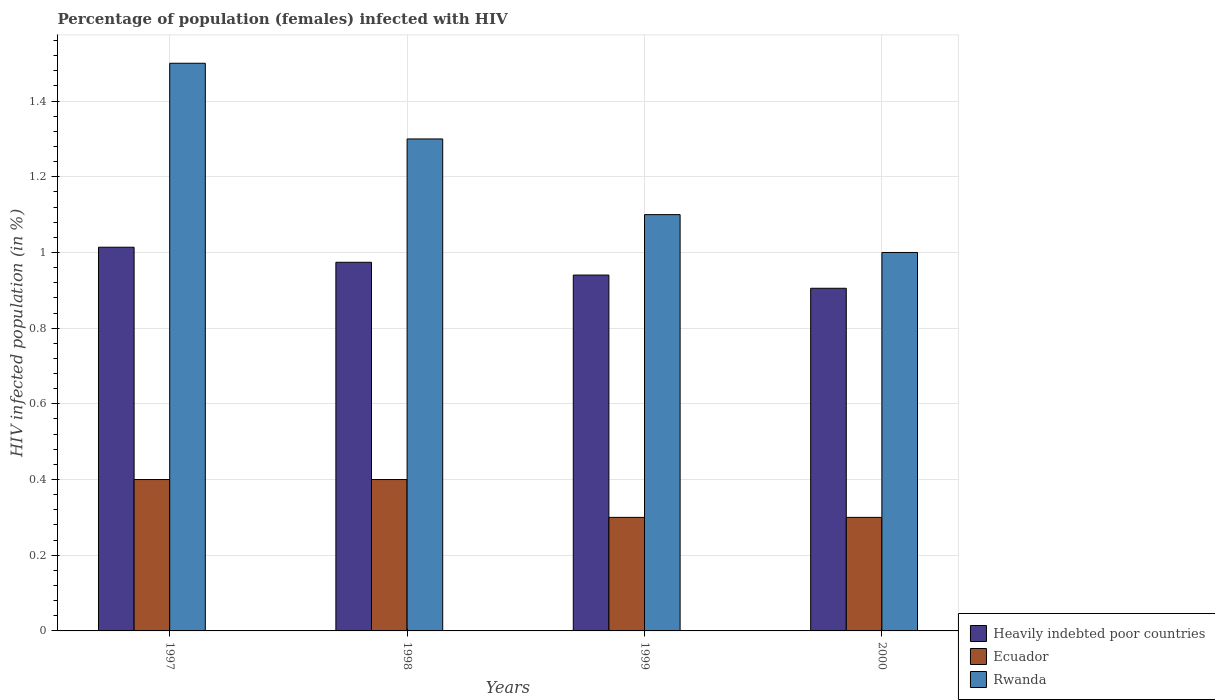How many different coloured bars are there?
Offer a very short reply. 3. How many groups of bars are there?
Offer a terse response. 4. Are the number of bars on each tick of the X-axis equal?
Provide a succinct answer. Yes. What is the label of the 4th group of bars from the left?
Provide a succinct answer. 2000. In how many cases, is the number of bars for a given year not equal to the number of legend labels?
Give a very brief answer. 0. Across all years, what is the maximum percentage of HIV infected female population in Heavily indebted poor countries?
Your answer should be compact. 1.01. In which year was the percentage of HIV infected female population in Heavily indebted poor countries maximum?
Ensure brevity in your answer.  1997. In which year was the percentage of HIV infected female population in Rwanda minimum?
Ensure brevity in your answer.  2000. What is the total percentage of HIV infected female population in Ecuador in the graph?
Provide a succinct answer. 1.4. What is the difference between the percentage of HIV infected female population in Ecuador in 1998 and that in 1999?
Offer a very short reply. 0.1. What is the average percentage of HIV infected female population in Rwanda per year?
Your answer should be very brief. 1.23. In the year 1997, what is the difference between the percentage of HIV infected female population in Heavily indebted poor countries and percentage of HIV infected female population in Rwanda?
Ensure brevity in your answer.  -0.49. What is the ratio of the percentage of HIV infected female population in Rwanda in 1998 to that in 2000?
Your answer should be compact. 1.3. Is the difference between the percentage of HIV infected female population in Heavily indebted poor countries in 1998 and 2000 greater than the difference between the percentage of HIV infected female population in Rwanda in 1998 and 2000?
Provide a succinct answer. No. What is the difference between the highest and the second highest percentage of HIV infected female population in Ecuador?
Offer a very short reply. 0. What does the 1st bar from the left in 2000 represents?
Your answer should be very brief. Heavily indebted poor countries. What does the 3rd bar from the right in 1998 represents?
Provide a short and direct response. Heavily indebted poor countries. How many bars are there?
Offer a terse response. 12. Are all the bars in the graph horizontal?
Your answer should be very brief. No. Does the graph contain grids?
Provide a succinct answer. Yes. Where does the legend appear in the graph?
Provide a succinct answer. Bottom right. How are the legend labels stacked?
Provide a succinct answer. Vertical. What is the title of the graph?
Offer a very short reply. Percentage of population (females) infected with HIV. Does "Croatia" appear as one of the legend labels in the graph?
Your response must be concise. No. What is the label or title of the Y-axis?
Give a very brief answer. HIV infected population (in %). What is the HIV infected population (in %) in Heavily indebted poor countries in 1997?
Offer a very short reply. 1.01. What is the HIV infected population (in %) of Ecuador in 1997?
Provide a short and direct response. 0.4. What is the HIV infected population (in %) of Rwanda in 1997?
Give a very brief answer. 1.5. What is the HIV infected population (in %) of Heavily indebted poor countries in 1998?
Make the answer very short. 0.97. What is the HIV infected population (in %) in Ecuador in 1998?
Offer a very short reply. 0.4. What is the HIV infected population (in %) of Heavily indebted poor countries in 1999?
Offer a terse response. 0.94. What is the HIV infected population (in %) in Rwanda in 1999?
Ensure brevity in your answer.  1.1. What is the HIV infected population (in %) of Heavily indebted poor countries in 2000?
Give a very brief answer. 0.91. Across all years, what is the maximum HIV infected population (in %) in Heavily indebted poor countries?
Offer a terse response. 1.01. Across all years, what is the maximum HIV infected population (in %) in Ecuador?
Your answer should be compact. 0.4. Across all years, what is the maximum HIV infected population (in %) in Rwanda?
Ensure brevity in your answer.  1.5. Across all years, what is the minimum HIV infected population (in %) in Heavily indebted poor countries?
Provide a short and direct response. 0.91. What is the total HIV infected population (in %) in Heavily indebted poor countries in the graph?
Provide a short and direct response. 3.83. What is the difference between the HIV infected population (in %) of Heavily indebted poor countries in 1997 and that in 1998?
Your response must be concise. 0.04. What is the difference between the HIV infected population (in %) in Ecuador in 1997 and that in 1998?
Give a very brief answer. 0. What is the difference between the HIV infected population (in %) in Heavily indebted poor countries in 1997 and that in 1999?
Give a very brief answer. 0.07. What is the difference between the HIV infected population (in %) in Rwanda in 1997 and that in 1999?
Keep it short and to the point. 0.4. What is the difference between the HIV infected population (in %) in Heavily indebted poor countries in 1997 and that in 2000?
Ensure brevity in your answer.  0.11. What is the difference between the HIV infected population (in %) of Heavily indebted poor countries in 1998 and that in 1999?
Offer a very short reply. 0.03. What is the difference between the HIV infected population (in %) of Heavily indebted poor countries in 1998 and that in 2000?
Keep it short and to the point. 0.07. What is the difference between the HIV infected population (in %) in Rwanda in 1998 and that in 2000?
Give a very brief answer. 0.3. What is the difference between the HIV infected population (in %) of Heavily indebted poor countries in 1999 and that in 2000?
Your answer should be very brief. 0.03. What is the difference between the HIV infected population (in %) of Ecuador in 1999 and that in 2000?
Provide a succinct answer. 0. What is the difference between the HIV infected population (in %) in Heavily indebted poor countries in 1997 and the HIV infected population (in %) in Ecuador in 1998?
Ensure brevity in your answer.  0.61. What is the difference between the HIV infected population (in %) in Heavily indebted poor countries in 1997 and the HIV infected population (in %) in Rwanda in 1998?
Provide a succinct answer. -0.29. What is the difference between the HIV infected population (in %) of Heavily indebted poor countries in 1997 and the HIV infected population (in %) of Ecuador in 1999?
Keep it short and to the point. 0.71. What is the difference between the HIV infected population (in %) in Heavily indebted poor countries in 1997 and the HIV infected population (in %) in Rwanda in 1999?
Your response must be concise. -0.09. What is the difference between the HIV infected population (in %) of Ecuador in 1997 and the HIV infected population (in %) of Rwanda in 1999?
Your answer should be very brief. -0.7. What is the difference between the HIV infected population (in %) in Heavily indebted poor countries in 1997 and the HIV infected population (in %) in Ecuador in 2000?
Keep it short and to the point. 0.71. What is the difference between the HIV infected population (in %) in Heavily indebted poor countries in 1997 and the HIV infected population (in %) in Rwanda in 2000?
Make the answer very short. 0.01. What is the difference between the HIV infected population (in %) in Ecuador in 1997 and the HIV infected population (in %) in Rwanda in 2000?
Your answer should be compact. -0.6. What is the difference between the HIV infected population (in %) of Heavily indebted poor countries in 1998 and the HIV infected population (in %) of Ecuador in 1999?
Ensure brevity in your answer.  0.67. What is the difference between the HIV infected population (in %) in Heavily indebted poor countries in 1998 and the HIV infected population (in %) in Rwanda in 1999?
Ensure brevity in your answer.  -0.13. What is the difference between the HIV infected population (in %) in Ecuador in 1998 and the HIV infected population (in %) in Rwanda in 1999?
Ensure brevity in your answer.  -0.7. What is the difference between the HIV infected population (in %) in Heavily indebted poor countries in 1998 and the HIV infected population (in %) in Ecuador in 2000?
Offer a very short reply. 0.67. What is the difference between the HIV infected population (in %) of Heavily indebted poor countries in 1998 and the HIV infected population (in %) of Rwanda in 2000?
Offer a very short reply. -0.03. What is the difference between the HIV infected population (in %) of Heavily indebted poor countries in 1999 and the HIV infected population (in %) of Ecuador in 2000?
Ensure brevity in your answer.  0.64. What is the difference between the HIV infected population (in %) of Heavily indebted poor countries in 1999 and the HIV infected population (in %) of Rwanda in 2000?
Offer a terse response. -0.06. What is the average HIV infected population (in %) of Heavily indebted poor countries per year?
Offer a terse response. 0.96. What is the average HIV infected population (in %) of Ecuador per year?
Keep it short and to the point. 0.35. What is the average HIV infected population (in %) of Rwanda per year?
Offer a very short reply. 1.23. In the year 1997, what is the difference between the HIV infected population (in %) in Heavily indebted poor countries and HIV infected population (in %) in Ecuador?
Ensure brevity in your answer.  0.61. In the year 1997, what is the difference between the HIV infected population (in %) in Heavily indebted poor countries and HIV infected population (in %) in Rwanda?
Provide a short and direct response. -0.49. In the year 1997, what is the difference between the HIV infected population (in %) of Ecuador and HIV infected population (in %) of Rwanda?
Make the answer very short. -1.1. In the year 1998, what is the difference between the HIV infected population (in %) in Heavily indebted poor countries and HIV infected population (in %) in Ecuador?
Provide a succinct answer. 0.57. In the year 1998, what is the difference between the HIV infected population (in %) in Heavily indebted poor countries and HIV infected population (in %) in Rwanda?
Provide a short and direct response. -0.33. In the year 1999, what is the difference between the HIV infected population (in %) of Heavily indebted poor countries and HIV infected population (in %) of Ecuador?
Your answer should be very brief. 0.64. In the year 1999, what is the difference between the HIV infected population (in %) in Heavily indebted poor countries and HIV infected population (in %) in Rwanda?
Provide a short and direct response. -0.16. In the year 1999, what is the difference between the HIV infected population (in %) of Ecuador and HIV infected population (in %) of Rwanda?
Offer a very short reply. -0.8. In the year 2000, what is the difference between the HIV infected population (in %) in Heavily indebted poor countries and HIV infected population (in %) in Ecuador?
Give a very brief answer. 0.61. In the year 2000, what is the difference between the HIV infected population (in %) of Heavily indebted poor countries and HIV infected population (in %) of Rwanda?
Provide a short and direct response. -0.09. What is the ratio of the HIV infected population (in %) of Heavily indebted poor countries in 1997 to that in 1998?
Your answer should be compact. 1.04. What is the ratio of the HIV infected population (in %) of Rwanda in 1997 to that in 1998?
Give a very brief answer. 1.15. What is the ratio of the HIV infected population (in %) of Heavily indebted poor countries in 1997 to that in 1999?
Give a very brief answer. 1.08. What is the ratio of the HIV infected population (in %) in Rwanda in 1997 to that in 1999?
Offer a very short reply. 1.36. What is the ratio of the HIV infected population (in %) of Heavily indebted poor countries in 1997 to that in 2000?
Ensure brevity in your answer.  1.12. What is the ratio of the HIV infected population (in %) of Ecuador in 1997 to that in 2000?
Offer a terse response. 1.33. What is the ratio of the HIV infected population (in %) in Rwanda in 1997 to that in 2000?
Provide a short and direct response. 1.5. What is the ratio of the HIV infected population (in %) in Heavily indebted poor countries in 1998 to that in 1999?
Make the answer very short. 1.04. What is the ratio of the HIV infected population (in %) in Ecuador in 1998 to that in 1999?
Keep it short and to the point. 1.33. What is the ratio of the HIV infected population (in %) of Rwanda in 1998 to that in 1999?
Your response must be concise. 1.18. What is the ratio of the HIV infected population (in %) in Heavily indebted poor countries in 1998 to that in 2000?
Offer a very short reply. 1.08. What is the ratio of the HIV infected population (in %) of Ecuador in 1998 to that in 2000?
Your answer should be compact. 1.33. What is the ratio of the HIV infected population (in %) in Rwanda in 1998 to that in 2000?
Your answer should be very brief. 1.3. What is the ratio of the HIV infected population (in %) of Heavily indebted poor countries in 1999 to that in 2000?
Offer a terse response. 1.04. What is the ratio of the HIV infected population (in %) of Ecuador in 1999 to that in 2000?
Your answer should be compact. 1. What is the difference between the highest and the second highest HIV infected population (in %) in Heavily indebted poor countries?
Ensure brevity in your answer.  0.04. What is the difference between the highest and the second highest HIV infected population (in %) of Rwanda?
Make the answer very short. 0.2. What is the difference between the highest and the lowest HIV infected population (in %) of Heavily indebted poor countries?
Offer a very short reply. 0.11. What is the difference between the highest and the lowest HIV infected population (in %) in Rwanda?
Provide a succinct answer. 0.5. 